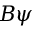Convert formula to latex. <formula><loc_0><loc_0><loc_500><loc_500>B \psi</formula> 